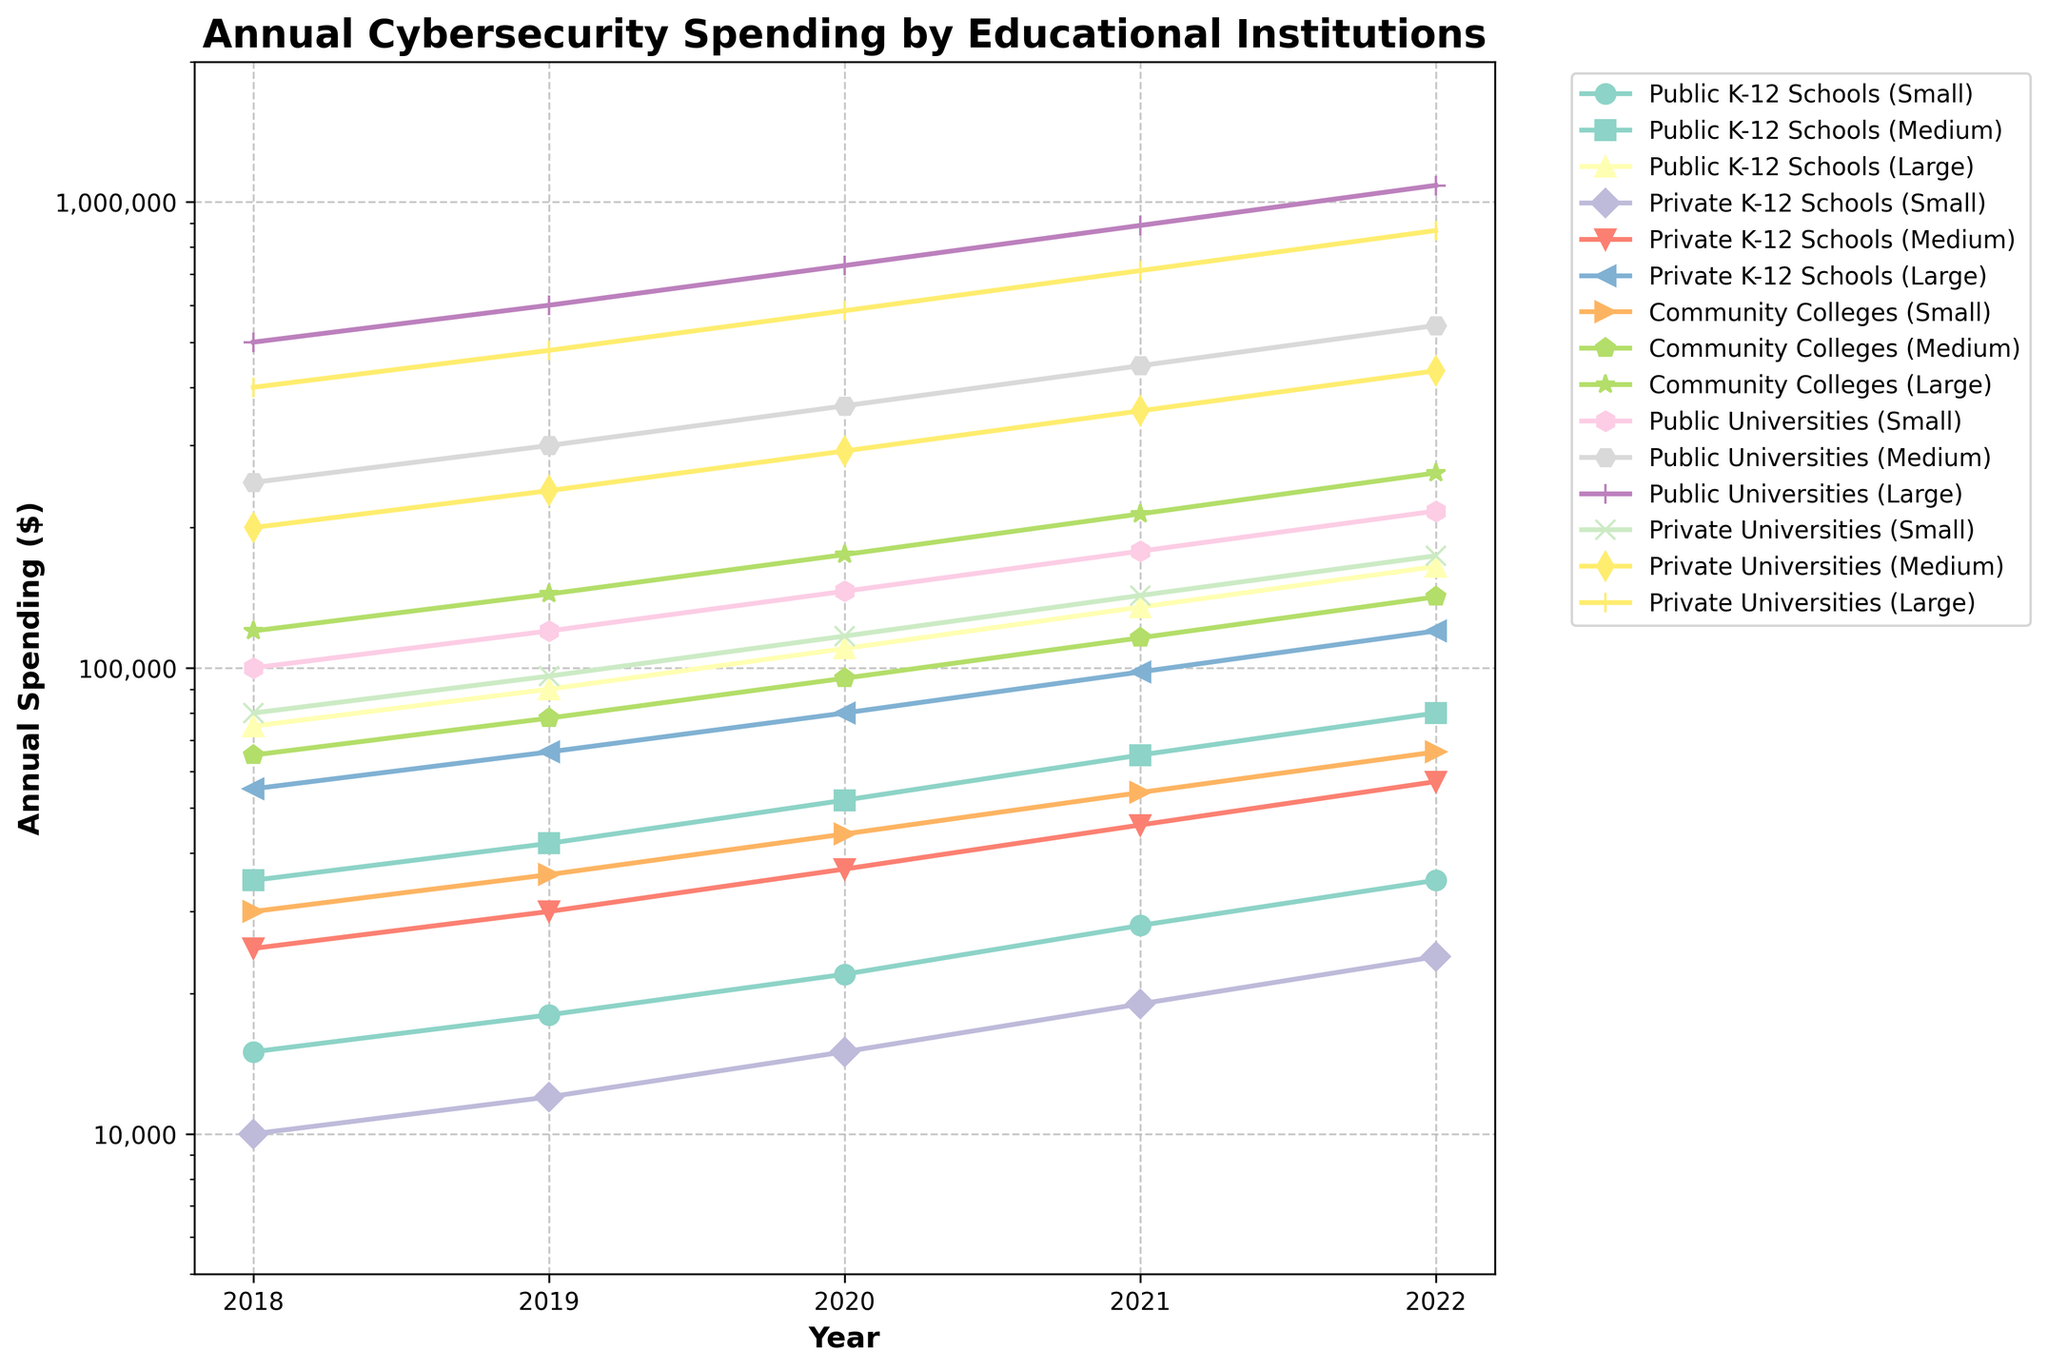What is the general trend of cybersecurity spending for Public Universities (Large) from 2018 to 2022? From the line chart, observe the plotted line corresponding to Public Universities (Large). Notice how the spending amount increases every year. It starts at $500,000 in 2018 and rises to $1,085,000 in 2022. Therefore, the general trend is consistently upward.
Answer: Upward trend Which institution type and size had the highest spending in 2022? Scan the rightmost end of the plot to see the final data point of each line. The highest point in 2022 is marked by Public Universities (Large), at $1,085,000.
Answer: Public Universities (Large) What was the difference in spending between Public K-12 Schools (Small) and Private K-12 Schools (Small) in 2022? Locate the data points for 2022 corresponding to Public K-12 Schools (Small) and Private K-12 Schools (Small). The points are at $35,000 and $24,000 respectively. The difference is $35,000 - $24,000 = $11,000.
Answer: $11,000 By how much did Community Colleges (Large) increase their spending from 2018 to 2022? Find the starting and ending points for Community Colleges (Large). In 2018, the spending was $120,000 and in 2022, it was $262,000. The difference is $262,000 - $120,000 = $142,000.
Answer: $142,000 Which institution type and size had the lowest spending in 2019, and how much was it? Focus on the 2019 data points and identify the lowest one. The line for Private K-12 Schools (Small) is lowest at that point, with $12,000.
Answer: Private K-12 Schools (Small), $12,000 Did Public Universities (Medium) or Private Universities (Medium) have higher spending in 2020? By how much? Find the 2020 spending points for Public Universities (Medium) and Private Universities (Medium). Public Universities (Medium) spent $365,000 while Private Universities (Medium) spent $292,000. The difference is $365,000 - $292,000 = $73,000.
Answer: Public Universities (Medium), $73,000 For which year did Public K-12 Schools (Large) see the highest single-year increase in spending, and what was the increase? Compare consecutive years for Public K-12 Schools (Large). The biggest increase occurred between 2021 ($135,000) and 2022 ($165,000), calculated as $165,000 - $135,000 = $30,000.
Answer: 2022, $30,000 What is the average spending for Private Universities (Large) from 2018 to 2022? Add the annual spending for Private Universities (Large) from 2018 to 2022: $400,000, $480,000, $584,000, $712,000, $868,000. The sum is $3,044,000. Divide by 5 to get the average: $3,044,000 / 5 = $608,800.
Answer: $608,800 In 2021, which had a greater increase in spending compared to 2020: Community Colleges (Medium) or Private Universities (Small)? By how much? Determine the difference between 2021 and 2020 for both institutions. Community Colleges (Medium): $116,000 (2021) - $95,000 (2020) = $21,000. Private Universities (Small): $143,000 (2021) - $117,000 (2020) = $26,000. The greater increase was by Private Universities (Small) by $26,000 - $21,000 = $5,000.
Answer: Private Universities (Small), $5,000 